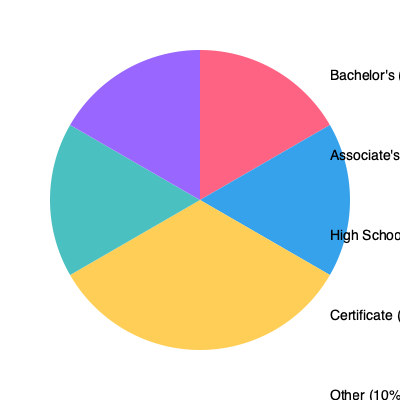As a corporate recruiter, you're analyzing a pie chart showing the distribution of entry-level jobs by educational requirements. What percentage of entry-level jobs require either a high school diploma or an associate's degree? To answer this question, we need to follow these steps:

1. Identify the percentages for high school diploma and associate's degree requirements:
   - High School: 20%
   - Associate's: 25%

2. Add these two percentages together:
   $20\% + 25\% = 45\%$

3. Interpret the result:
   This means that 45% of entry-level jobs require either a high school diploma or an associate's degree.

4. Consider the implications for job seekers:
   While this data shows that a significant portion of entry-level jobs are accessible with these education levels, it's important to remember that following one's passion can lead to greater job satisfaction and success in the long run. Encourage job seekers to consider their interests and skills alongside market demands when making career decisions.
Answer: 45% 